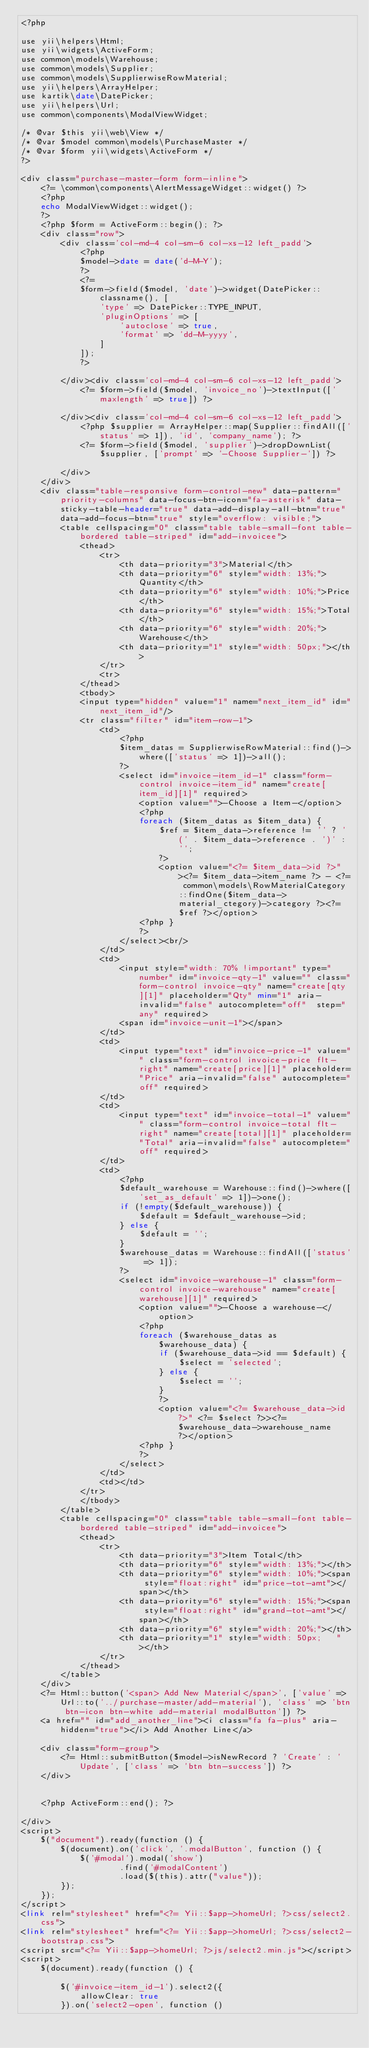<code> <loc_0><loc_0><loc_500><loc_500><_PHP_><?php

use yii\helpers\Html;
use yii\widgets\ActiveForm;
use common\models\Warehouse;
use common\models\Supplier;
use common\models\SupplierwiseRowMaterial;
use yii\helpers\ArrayHelper;
use kartik\date\DatePicker;
use yii\helpers\Url;
use common\components\ModalViewWidget;

/* @var $this yii\web\View */
/* @var $model common\models\PurchaseMaster */
/* @var $form yii\widgets\ActiveForm */
?>

<div class="purchase-master-form form-inline">
    <?= \common\components\AlertMessageWidget::widget() ?>
    <?php
    echo ModalViewWidget::widget();
    ?>
    <?php $form = ActiveForm::begin(); ?>
    <div class="row">
        <div class='col-md-4 col-sm-6 col-xs-12 left_padd'>
            <?php
            $model->date = date('d-M-Y');
            ?>
            <?=
            $form->field($model, 'date')->widget(DatePicker::classname(), [
                'type' => DatePicker::TYPE_INPUT,
                'pluginOptions' => [
                    'autoclose' => true,
                    'format' => 'dd-M-yyyy',
                ]
            ]);
            ?>

        </div><div class='col-md-4 col-sm-6 col-xs-12 left_padd'>
            <?= $form->field($model, 'invoice_no')->textInput(['maxlength' => true]) ?>

        </div><div class='col-md-4 col-sm-6 col-xs-12 left_padd'>
            <?php $supplier = ArrayHelper::map(Supplier::findAll(['status' => 1]), 'id', 'company_name'); ?>
            <?= $form->field($model, 'supplier')->dropDownList($supplier, ['prompt' => '-Choose Supplier-']) ?>

        </div>
    </div>
    <div class="table-responsive form-control-new" data-pattern="priority-columns" data-focus-btn-icon="fa-asterisk" data-sticky-table-header="true" data-add-display-all-btn="true" data-add-focus-btn="true" style="overflow: visible;">
        <table cellspacing="0" class="table table-small-font table-bordered table-striped" id="add-invoicee">
            <thead>
                <tr>
                    <th data-priority="3">Material</th>
                    <th data-priority="6" style="width: 13%;">Quantity</th>
                    <th data-priority="6" style="width: 10%;">Price</th>
                    <th data-priority="6" style="width: 15%;">Total</th>
                    <th data-priority="6" style="width: 20%;">Warehouse</th>
                    <th data-priority="1" style="width: 50px;"></th>
                </tr>
                <tr>
            </thead>
            <tbody>
            <input type="hidden" value="1" name="next_item_id" id="next_item_id"/>
            <tr class="filter" id="item-row-1">
                <td>
                    <?php
                    $item_datas = SupplierwiseRowMaterial::find()->where(['status' => 1])->all();
                    ?>
                    <select id="invoice-item_id-1" class="form-control invoice-item_id" name="create[item_id][1]" required>
                        <option value="">-Choose a Item-</option>
                        <?php
                        foreach ($item_datas as $item_data) {
                            $ref = $item_data->reference != '' ? ' (' . $item_data->reference . ')' : '';
                            ?>
                            <option value="<?= $item_data->id ?>"><?= $item_data->item_name ?> - <?= common\models\RowMaterialCategory::findOne($item_data->material_ctegory)->category ?><?= $ref ?></option>
                        <?php }
                        ?>
                    </select><br/>
                </td>
                <td>
                    <input style="width: 70% !important" type="number" id="invoice-qty-1" value="" class="form-control invoice-qty" name="create[qty][1]" placeholder="Qty" min="1" aria-invalid="false" autocomplete="off"  step="any" required>
                    <span id="invoice-unit-1"></span>
                </td>
                <td>
                    <input type="text" id="invoice-price-1" value="" class="form-control invoice-price flt-right" name="create[price][1]" placeholder="Price" aria-invalid="false" autocomplete="off" required>
                </td>
                <td>
                    <input type="text" id="invoice-total-1" value="" class="form-control invoice-total flt-right" name="create[total][1]" placeholder="Total" aria-invalid="false" autocomplete="off" required>
                </td>
                <td>
                    <?php
                    $default_warehouse = Warehouse::find()->where(['set_as_default' => 1])->one();
                    if (!empty($default_warehouse)) {
                        $default = $default_warehouse->id;
                    } else {
                        $default = '';
                    }
                    $warehouse_datas = Warehouse::findAll(['status' => 1]);
                    ?>
                    <select id="invoice-warehouse-1" class="form-control invoice-warehouse" name="create[warehouse][1]" required>
                        <option value="">-Choose a warehouse-</option>
                        <?php
                        foreach ($warehouse_datas as $warehouse_data) {
                            if ($warehouse_data->id == $default) {
                                $select = 'selected';
                            } else {
                                $select = '';
                            }
                            ?>
                            <option value="<?= $warehouse_data->id ?>" <?= $select ?>><?= $warehouse_data->warehouse_name ?></option>
                        <?php }
                        ?>
                    </select>
                </td>
                <td></td>
            </tr>
            </tbody>
        </table>
        <table cellspacing="0" class="table table-small-font table-bordered table-striped" id="add-invoicee">
            <thead>
                <tr>
                    <th data-priority="3">Item Total</th>
                    <th data-priority="6" style="width: 13%;"></th>
                    <th data-priority="6" style="width: 10%;"><span style="float:right" id="price-tot-amt"></span></th>
                    <th data-priority="6" style="width: 15%;"><span style="float:right" id="grand-tot-amt"></span></th>
                    <th data-priority="6" style="width: 20%;"></th>
                    <th data-priority="1" style="width: 50px;   "></th>
                </tr>
            </thead>
        </table>
    </div>
    <?= Html::button('<span> Add New Material</span>', ['value' => Url::to('../purchase-master/add-material'), 'class' => 'btn btn-icon btn-white add-material modalButton']) ?>
    <a href="" id="add_another_line"><i class="fa fa-plus" aria-hidden="true"></i> Add Another Line</a>

    <div class="form-group">
        <?= Html::submitButton($model->isNewRecord ? 'Create' : 'Update', ['class' => 'btn btn-success']) ?>
    </div>


    <?php ActiveForm::end(); ?>

</div>
<script>
    $("document").ready(function () {
        $(document).on('click', '.modalButton', function () {
            $('#modal').modal('show')
                    .find('#modalContent')
                    .load($(this).attr("value"));
        });
    });
</script>
<link rel="stylesheet" href="<?= Yii::$app->homeUrl; ?>css/select2.css">
<link rel="stylesheet" href="<?= Yii::$app->homeUrl; ?>css/select2-bootstrap.css">
<script src="<?= Yii::$app->homeUrl; ?>js/select2.min.js"></script>
<script>
    $(document).ready(function () {

        $('#invoice-item_id-1').select2({
            allowClear: true
        }).on('select2-open', function ()</code> 